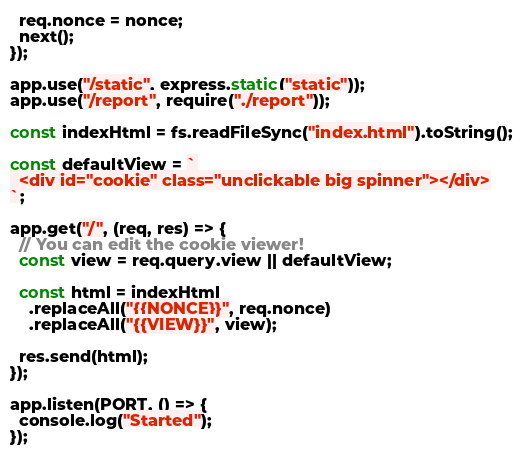Convert code to text. <code><loc_0><loc_0><loc_500><loc_500><_JavaScript_>  req.nonce = nonce;
  next();
});

app.use("/static", express.static("static"));
app.use("/report", require("./report"));

const indexHtml = fs.readFileSync("index.html").toString();

const defaultView = `
  <div id="cookie" class="unclickable big spinner"></div>
`;

app.get("/", (req, res) => {
  // You can edit the cookie viewer!
  const view = req.query.view || defaultView;

  const html = indexHtml
    .replaceAll("{{NONCE}}", req.nonce)
    .replaceAll("{{VIEW}}", view);

  res.send(html);
});

app.listen(PORT, () => {
  console.log("Started");
});
</code> 